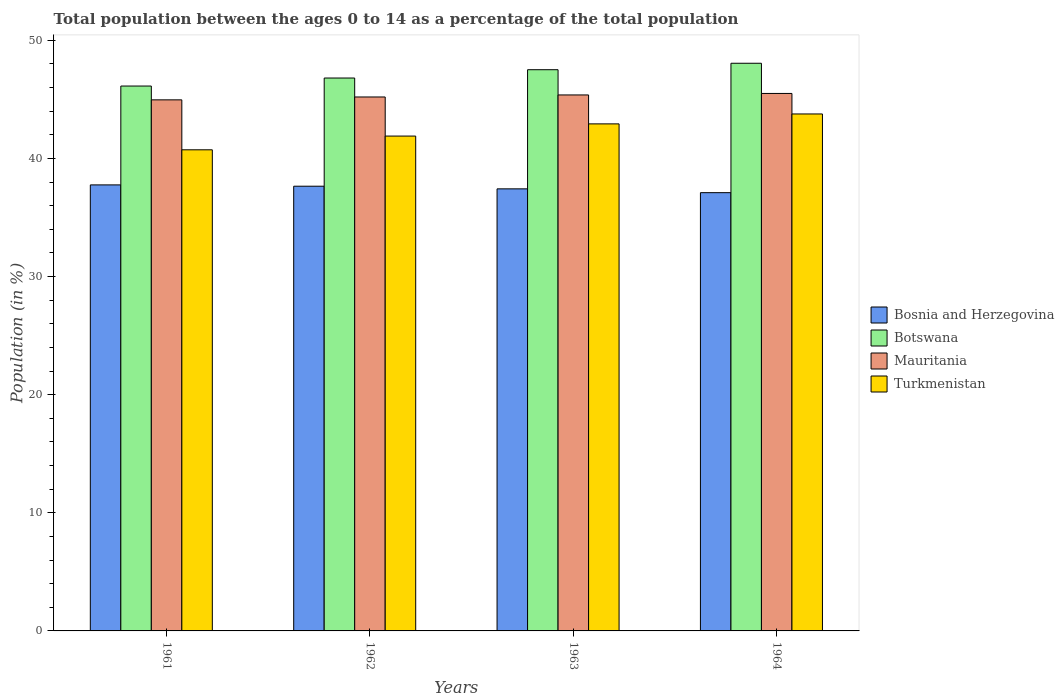How many groups of bars are there?
Offer a very short reply. 4. How many bars are there on the 1st tick from the right?
Offer a terse response. 4. What is the percentage of the population ages 0 to 14 in Bosnia and Herzegovina in 1963?
Your answer should be very brief. 37.42. Across all years, what is the maximum percentage of the population ages 0 to 14 in Bosnia and Herzegovina?
Offer a very short reply. 37.76. Across all years, what is the minimum percentage of the population ages 0 to 14 in Turkmenistan?
Provide a short and direct response. 40.73. In which year was the percentage of the population ages 0 to 14 in Botswana maximum?
Your answer should be compact. 1964. What is the total percentage of the population ages 0 to 14 in Bosnia and Herzegovina in the graph?
Offer a terse response. 149.93. What is the difference between the percentage of the population ages 0 to 14 in Botswana in 1961 and that in 1962?
Give a very brief answer. -0.68. What is the difference between the percentage of the population ages 0 to 14 in Botswana in 1962 and the percentage of the population ages 0 to 14 in Mauritania in 1964?
Give a very brief answer. 1.31. What is the average percentage of the population ages 0 to 14 in Botswana per year?
Provide a short and direct response. 47.12. In the year 1964, what is the difference between the percentage of the population ages 0 to 14 in Bosnia and Herzegovina and percentage of the population ages 0 to 14 in Botswana?
Provide a succinct answer. -10.95. What is the ratio of the percentage of the population ages 0 to 14 in Mauritania in 1961 to that in 1964?
Your answer should be compact. 0.99. Is the percentage of the population ages 0 to 14 in Bosnia and Herzegovina in 1961 less than that in 1964?
Make the answer very short. No. Is the difference between the percentage of the population ages 0 to 14 in Bosnia and Herzegovina in 1963 and 1964 greater than the difference between the percentage of the population ages 0 to 14 in Botswana in 1963 and 1964?
Ensure brevity in your answer.  Yes. What is the difference between the highest and the second highest percentage of the population ages 0 to 14 in Botswana?
Give a very brief answer. 0.55. What is the difference between the highest and the lowest percentage of the population ages 0 to 14 in Botswana?
Your answer should be compact. 1.93. In how many years, is the percentage of the population ages 0 to 14 in Botswana greater than the average percentage of the population ages 0 to 14 in Botswana taken over all years?
Your answer should be compact. 2. Is it the case that in every year, the sum of the percentage of the population ages 0 to 14 in Bosnia and Herzegovina and percentage of the population ages 0 to 14 in Mauritania is greater than the sum of percentage of the population ages 0 to 14 in Botswana and percentage of the population ages 0 to 14 in Turkmenistan?
Give a very brief answer. No. What does the 3rd bar from the left in 1964 represents?
Provide a succinct answer. Mauritania. What does the 3rd bar from the right in 1963 represents?
Offer a very short reply. Botswana. Is it the case that in every year, the sum of the percentage of the population ages 0 to 14 in Mauritania and percentage of the population ages 0 to 14 in Botswana is greater than the percentage of the population ages 0 to 14 in Turkmenistan?
Your answer should be compact. Yes. Are all the bars in the graph horizontal?
Offer a terse response. No. How many years are there in the graph?
Keep it short and to the point. 4. What is the difference between two consecutive major ticks on the Y-axis?
Give a very brief answer. 10. Are the values on the major ticks of Y-axis written in scientific E-notation?
Keep it short and to the point. No. How many legend labels are there?
Your answer should be very brief. 4. What is the title of the graph?
Your answer should be very brief. Total population between the ages 0 to 14 as a percentage of the total population. What is the Population (in %) in Bosnia and Herzegovina in 1961?
Your answer should be compact. 37.76. What is the Population (in %) of Botswana in 1961?
Your response must be concise. 46.13. What is the Population (in %) in Mauritania in 1961?
Provide a succinct answer. 44.96. What is the Population (in %) of Turkmenistan in 1961?
Offer a terse response. 40.73. What is the Population (in %) of Bosnia and Herzegovina in 1962?
Your answer should be very brief. 37.65. What is the Population (in %) in Botswana in 1962?
Your answer should be compact. 46.81. What is the Population (in %) in Mauritania in 1962?
Your answer should be compact. 45.2. What is the Population (in %) of Turkmenistan in 1962?
Your answer should be compact. 41.89. What is the Population (in %) in Bosnia and Herzegovina in 1963?
Your response must be concise. 37.42. What is the Population (in %) of Botswana in 1963?
Provide a succinct answer. 47.51. What is the Population (in %) of Mauritania in 1963?
Keep it short and to the point. 45.37. What is the Population (in %) in Turkmenistan in 1963?
Your answer should be very brief. 42.92. What is the Population (in %) of Bosnia and Herzegovina in 1964?
Your response must be concise. 37.1. What is the Population (in %) of Botswana in 1964?
Your response must be concise. 48.06. What is the Population (in %) of Mauritania in 1964?
Make the answer very short. 45.5. What is the Population (in %) in Turkmenistan in 1964?
Offer a very short reply. 43.76. Across all years, what is the maximum Population (in %) of Bosnia and Herzegovina?
Ensure brevity in your answer.  37.76. Across all years, what is the maximum Population (in %) in Botswana?
Provide a short and direct response. 48.06. Across all years, what is the maximum Population (in %) in Mauritania?
Provide a short and direct response. 45.5. Across all years, what is the maximum Population (in %) of Turkmenistan?
Make the answer very short. 43.76. Across all years, what is the minimum Population (in %) in Bosnia and Herzegovina?
Provide a short and direct response. 37.1. Across all years, what is the minimum Population (in %) in Botswana?
Your answer should be very brief. 46.13. Across all years, what is the minimum Population (in %) in Mauritania?
Keep it short and to the point. 44.96. Across all years, what is the minimum Population (in %) of Turkmenistan?
Provide a succinct answer. 40.73. What is the total Population (in %) of Bosnia and Herzegovina in the graph?
Ensure brevity in your answer.  149.93. What is the total Population (in %) in Botswana in the graph?
Provide a short and direct response. 188.5. What is the total Population (in %) in Mauritania in the graph?
Offer a very short reply. 181.03. What is the total Population (in %) of Turkmenistan in the graph?
Offer a very short reply. 169.31. What is the difference between the Population (in %) of Bosnia and Herzegovina in 1961 and that in 1962?
Provide a short and direct response. 0.11. What is the difference between the Population (in %) of Botswana in 1961 and that in 1962?
Make the answer very short. -0.68. What is the difference between the Population (in %) of Mauritania in 1961 and that in 1962?
Keep it short and to the point. -0.24. What is the difference between the Population (in %) of Turkmenistan in 1961 and that in 1962?
Your answer should be compact. -1.16. What is the difference between the Population (in %) of Bosnia and Herzegovina in 1961 and that in 1963?
Keep it short and to the point. 0.34. What is the difference between the Population (in %) of Botswana in 1961 and that in 1963?
Give a very brief answer. -1.38. What is the difference between the Population (in %) of Mauritania in 1961 and that in 1963?
Provide a succinct answer. -0.42. What is the difference between the Population (in %) in Turkmenistan in 1961 and that in 1963?
Your answer should be very brief. -2.2. What is the difference between the Population (in %) of Bosnia and Herzegovina in 1961 and that in 1964?
Provide a succinct answer. 0.66. What is the difference between the Population (in %) of Botswana in 1961 and that in 1964?
Make the answer very short. -1.93. What is the difference between the Population (in %) of Mauritania in 1961 and that in 1964?
Ensure brevity in your answer.  -0.54. What is the difference between the Population (in %) in Turkmenistan in 1961 and that in 1964?
Keep it short and to the point. -3.03. What is the difference between the Population (in %) in Bosnia and Herzegovina in 1962 and that in 1963?
Your response must be concise. 0.22. What is the difference between the Population (in %) of Botswana in 1962 and that in 1963?
Ensure brevity in your answer.  -0.7. What is the difference between the Population (in %) in Mauritania in 1962 and that in 1963?
Keep it short and to the point. -0.17. What is the difference between the Population (in %) of Turkmenistan in 1962 and that in 1963?
Provide a short and direct response. -1.03. What is the difference between the Population (in %) in Bosnia and Herzegovina in 1962 and that in 1964?
Offer a very short reply. 0.55. What is the difference between the Population (in %) of Botswana in 1962 and that in 1964?
Your answer should be very brief. -1.25. What is the difference between the Population (in %) of Mauritania in 1962 and that in 1964?
Offer a very short reply. -0.3. What is the difference between the Population (in %) in Turkmenistan in 1962 and that in 1964?
Ensure brevity in your answer.  -1.87. What is the difference between the Population (in %) of Bosnia and Herzegovina in 1963 and that in 1964?
Your answer should be compact. 0.32. What is the difference between the Population (in %) of Botswana in 1963 and that in 1964?
Keep it short and to the point. -0.55. What is the difference between the Population (in %) in Mauritania in 1963 and that in 1964?
Your answer should be very brief. -0.13. What is the difference between the Population (in %) of Turkmenistan in 1963 and that in 1964?
Your answer should be compact. -0.84. What is the difference between the Population (in %) of Bosnia and Herzegovina in 1961 and the Population (in %) of Botswana in 1962?
Your answer should be compact. -9.05. What is the difference between the Population (in %) in Bosnia and Herzegovina in 1961 and the Population (in %) in Mauritania in 1962?
Ensure brevity in your answer.  -7.44. What is the difference between the Population (in %) of Bosnia and Herzegovina in 1961 and the Population (in %) of Turkmenistan in 1962?
Offer a very short reply. -4.13. What is the difference between the Population (in %) of Botswana in 1961 and the Population (in %) of Mauritania in 1962?
Give a very brief answer. 0.93. What is the difference between the Population (in %) in Botswana in 1961 and the Population (in %) in Turkmenistan in 1962?
Provide a short and direct response. 4.24. What is the difference between the Population (in %) in Mauritania in 1961 and the Population (in %) in Turkmenistan in 1962?
Offer a terse response. 3.07. What is the difference between the Population (in %) in Bosnia and Herzegovina in 1961 and the Population (in %) in Botswana in 1963?
Offer a terse response. -9.75. What is the difference between the Population (in %) of Bosnia and Herzegovina in 1961 and the Population (in %) of Mauritania in 1963?
Offer a terse response. -7.61. What is the difference between the Population (in %) of Bosnia and Herzegovina in 1961 and the Population (in %) of Turkmenistan in 1963?
Your answer should be very brief. -5.17. What is the difference between the Population (in %) in Botswana in 1961 and the Population (in %) in Mauritania in 1963?
Give a very brief answer. 0.75. What is the difference between the Population (in %) of Botswana in 1961 and the Population (in %) of Turkmenistan in 1963?
Keep it short and to the point. 3.2. What is the difference between the Population (in %) of Mauritania in 1961 and the Population (in %) of Turkmenistan in 1963?
Your response must be concise. 2.03. What is the difference between the Population (in %) in Bosnia and Herzegovina in 1961 and the Population (in %) in Botswana in 1964?
Give a very brief answer. -10.3. What is the difference between the Population (in %) of Bosnia and Herzegovina in 1961 and the Population (in %) of Mauritania in 1964?
Provide a succinct answer. -7.74. What is the difference between the Population (in %) of Bosnia and Herzegovina in 1961 and the Population (in %) of Turkmenistan in 1964?
Your answer should be very brief. -6. What is the difference between the Population (in %) in Botswana in 1961 and the Population (in %) in Mauritania in 1964?
Offer a terse response. 0.63. What is the difference between the Population (in %) in Botswana in 1961 and the Population (in %) in Turkmenistan in 1964?
Your answer should be very brief. 2.36. What is the difference between the Population (in %) of Mauritania in 1961 and the Population (in %) of Turkmenistan in 1964?
Provide a short and direct response. 1.19. What is the difference between the Population (in %) in Bosnia and Herzegovina in 1962 and the Population (in %) in Botswana in 1963?
Offer a very short reply. -9.86. What is the difference between the Population (in %) of Bosnia and Herzegovina in 1962 and the Population (in %) of Mauritania in 1963?
Provide a short and direct response. -7.73. What is the difference between the Population (in %) in Bosnia and Herzegovina in 1962 and the Population (in %) in Turkmenistan in 1963?
Your answer should be compact. -5.28. What is the difference between the Population (in %) in Botswana in 1962 and the Population (in %) in Mauritania in 1963?
Keep it short and to the point. 1.43. What is the difference between the Population (in %) in Botswana in 1962 and the Population (in %) in Turkmenistan in 1963?
Ensure brevity in your answer.  3.88. What is the difference between the Population (in %) in Mauritania in 1962 and the Population (in %) in Turkmenistan in 1963?
Keep it short and to the point. 2.28. What is the difference between the Population (in %) of Bosnia and Herzegovina in 1962 and the Population (in %) of Botswana in 1964?
Make the answer very short. -10.41. What is the difference between the Population (in %) in Bosnia and Herzegovina in 1962 and the Population (in %) in Mauritania in 1964?
Make the answer very short. -7.85. What is the difference between the Population (in %) in Bosnia and Herzegovina in 1962 and the Population (in %) in Turkmenistan in 1964?
Your answer should be very brief. -6.12. What is the difference between the Population (in %) of Botswana in 1962 and the Population (in %) of Mauritania in 1964?
Your answer should be very brief. 1.31. What is the difference between the Population (in %) of Botswana in 1962 and the Population (in %) of Turkmenistan in 1964?
Give a very brief answer. 3.04. What is the difference between the Population (in %) of Mauritania in 1962 and the Population (in %) of Turkmenistan in 1964?
Your answer should be very brief. 1.44. What is the difference between the Population (in %) in Bosnia and Herzegovina in 1963 and the Population (in %) in Botswana in 1964?
Provide a succinct answer. -10.63. What is the difference between the Population (in %) in Bosnia and Herzegovina in 1963 and the Population (in %) in Mauritania in 1964?
Give a very brief answer. -8.08. What is the difference between the Population (in %) in Bosnia and Herzegovina in 1963 and the Population (in %) in Turkmenistan in 1964?
Provide a succinct answer. -6.34. What is the difference between the Population (in %) in Botswana in 1963 and the Population (in %) in Mauritania in 1964?
Your answer should be very brief. 2.01. What is the difference between the Population (in %) in Botswana in 1963 and the Population (in %) in Turkmenistan in 1964?
Provide a succinct answer. 3.75. What is the difference between the Population (in %) of Mauritania in 1963 and the Population (in %) of Turkmenistan in 1964?
Your response must be concise. 1.61. What is the average Population (in %) in Bosnia and Herzegovina per year?
Your response must be concise. 37.48. What is the average Population (in %) of Botswana per year?
Keep it short and to the point. 47.12. What is the average Population (in %) of Mauritania per year?
Offer a very short reply. 45.26. What is the average Population (in %) in Turkmenistan per year?
Your answer should be very brief. 42.33. In the year 1961, what is the difference between the Population (in %) in Bosnia and Herzegovina and Population (in %) in Botswana?
Offer a terse response. -8.37. In the year 1961, what is the difference between the Population (in %) in Bosnia and Herzegovina and Population (in %) in Mauritania?
Give a very brief answer. -7.2. In the year 1961, what is the difference between the Population (in %) of Bosnia and Herzegovina and Population (in %) of Turkmenistan?
Give a very brief answer. -2.97. In the year 1961, what is the difference between the Population (in %) of Botswana and Population (in %) of Mauritania?
Your answer should be compact. 1.17. In the year 1961, what is the difference between the Population (in %) in Botswana and Population (in %) in Turkmenistan?
Your answer should be very brief. 5.4. In the year 1961, what is the difference between the Population (in %) of Mauritania and Population (in %) of Turkmenistan?
Keep it short and to the point. 4.23. In the year 1962, what is the difference between the Population (in %) in Bosnia and Herzegovina and Population (in %) in Botswana?
Ensure brevity in your answer.  -9.16. In the year 1962, what is the difference between the Population (in %) in Bosnia and Herzegovina and Population (in %) in Mauritania?
Provide a short and direct response. -7.55. In the year 1962, what is the difference between the Population (in %) of Bosnia and Herzegovina and Population (in %) of Turkmenistan?
Your answer should be compact. -4.24. In the year 1962, what is the difference between the Population (in %) of Botswana and Population (in %) of Mauritania?
Provide a short and direct response. 1.61. In the year 1962, what is the difference between the Population (in %) of Botswana and Population (in %) of Turkmenistan?
Provide a short and direct response. 4.92. In the year 1962, what is the difference between the Population (in %) in Mauritania and Population (in %) in Turkmenistan?
Ensure brevity in your answer.  3.31. In the year 1963, what is the difference between the Population (in %) of Bosnia and Herzegovina and Population (in %) of Botswana?
Your answer should be compact. -10.09. In the year 1963, what is the difference between the Population (in %) of Bosnia and Herzegovina and Population (in %) of Mauritania?
Your response must be concise. -7.95. In the year 1963, what is the difference between the Population (in %) in Bosnia and Herzegovina and Population (in %) in Turkmenistan?
Keep it short and to the point. -5.5. In the year 1963, what is the difference between the Population (in %) of Botswana and Population (in %) of Mauritania?
Provide a succinct answer. 2.14. In the year 1963, what is the difference between the Population (in %) in Botswana and Population (in %) in Turkmenistan?
Offer a very short reply. 4.58. In the year 1963, what is the difference between the Population (in %) in Mauritania and Population (in %) in Turkmenistan?
Offer a very short reply. 2.45. In the year 1964, what is the difference between the Population (in %) of Bosnia and Herzegovina and Population (in %) of Botswana?
Make the answer very short. -10.95. In the year 1964, what is the difference between the Population (in %) in Bosnia and Herzegovina and Population (in %) in Mauritania?
Provide a succinct answer. -8.4. In the year 1964, what is the difference between the Population (in %) in Bosnia and Herzegovina and Population (in %) in Turkmenistan?
Ensure brevity in your answer.  -6.66. In the year 1964, what is the difference between the Population (in %) of Botswana and Population (in %) of Mauritania?
Give a very brief answer. 2.56. In the year 1964, what is the difference between the Population (in %) in Botswana and Population (in %) in Turkmenistan?
Provide a succinct answer. 4.29. In the year 1964, what is the difference between the Population (in %) of Mauritania and Population (in %) of Turkmenistan?
Ensure brevity in your answer.  1.74. What is the ratio of the Population (in %) of Botswana in 1961 to that in 1962?
Your response must be concise. 0.99. What is the ratio of the Population (in %) of Turkmenistan in 1961 to that in 1962?
Your answer should be compact. 0.97. What is the ratio of the Population (in %) in Bosnia and Herzegovina in 1961 to that in 1963?
Offer a terse response. 1.01. What is the ratio of the Population (in %) of Botswana in 1961 to that in 1963?
Offer a very short reply. 0.97. What is the ratio of the Population (in %) in Mauritania in 1961 to that in 1963?
Your answer should be compact. 0.99. What is the ratio of the Population (in %) in Turkmenistan in 1961 to that in 1963?
Give a very brief answer. 0.95. What is the ratio of the Population (in %) of Bosnia and Herzegovina in 1961 to that in 1964?
Provide a succinct answer. 1.02. What is the ratio of the Population (in %) of Botswana in 1961 to that in 1964?
Provide a short and direct response. 0.96. What is the ratio of the Population (in %) in Mauritania in 1961 to that in 1964?
Offer a very short reply. 0.99. What is the ratio of the Population (in %) of Turkmenistan in 1961 to that in 1964?
Give a very brief answer. 0.93. What is the ratio of the Population (in %) of Botswana in 1962 to that in 1963?
Offer a very short reply. 0.99. What is the ratio of the Population (in %) in Turkmenistan in 1962 to that in 1963?
Offer a very short reply. 0.98. What is the ratio of the Population (in %) in Bosnia and Herzegovina in 1962 to that in 1964?
Make the answer very short. 1.01. What is the ratio of the Population (in %) in Turkmenistan in 1962 to that in 1964?
Provide a succinct answer. 0.96. What is the ratio of the Population (in %) of Bosnia and Herzegovina in 1963 to that in 1964?
Give a very brief answer. 1.01. What is the ratio of the Population (in %) of Mauritania in 1963 to that in 1964?
Offer a terse response. 1. What is the ratio of the Population (in %) of Turkmenistan in 1963 to that in 1964?
Offer a terse response. 0.98. What is the difference between the highest and the second highest Population (in %) of Bosnia and Herzegovina?
Offer a very short reply. 0.11. What is the difference between the highest and the second highest Population (in %) of Botswana?
Your answer should be very brief. 0.55. What is the difference between the highest and the second highest Population (in %) in Mauritania?
Give a very brief answer. 0.13. What is the difference between the highest and the second highest Population (in %) in Turkmenistan?
Offer a terse response. 0.84. What is the difference between the highest and the lowest Population (in %) of Bosnia and Herzegovina?
Offer a very short reply. 0.66. What is the difference between the highest and the lowest Population (in %) in Botswana?
Give a very brief answer. 1.93. What is the difference between the highest and the lowest Population (in %) of Mauritania?
Provide a succinct answer. 0.54. What is the difference between the highest and the lowest Population (in %) in Turkmenistan?
Your answer should be compact. 3.03. 